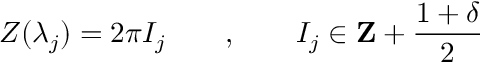Convert formula to latex. <formula><loc_0><loc_0><loc_500><loc_500>Z ( \lambda _ { j } ) = 2 \pi I _ { j } \quad , \quad I _ { j } \in Z + \frac { 1 + \delta } { 2 }</formula> 